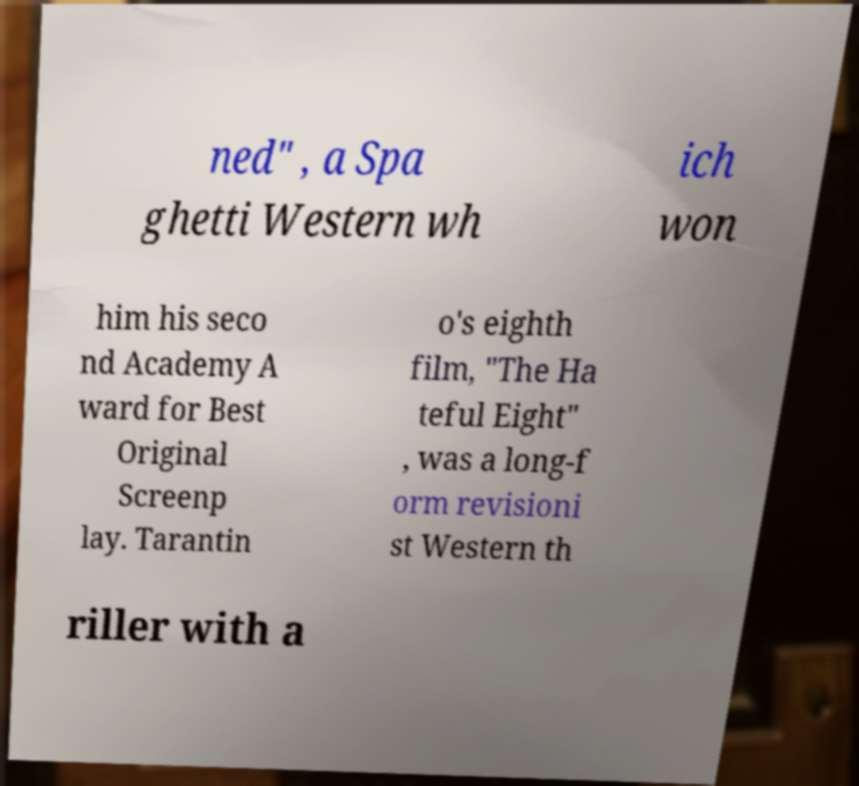There's text embedded in this image that I need extracted. Can you transcribe it verbatim? ned" , a Spa ghetti Western wh ich won him his seco nd Academy A ward for Best Original Screenp lay. Tarantin o's eighth film, "The Ha teful Eight" , was a long-f orm revisioni st Western th riller with a 